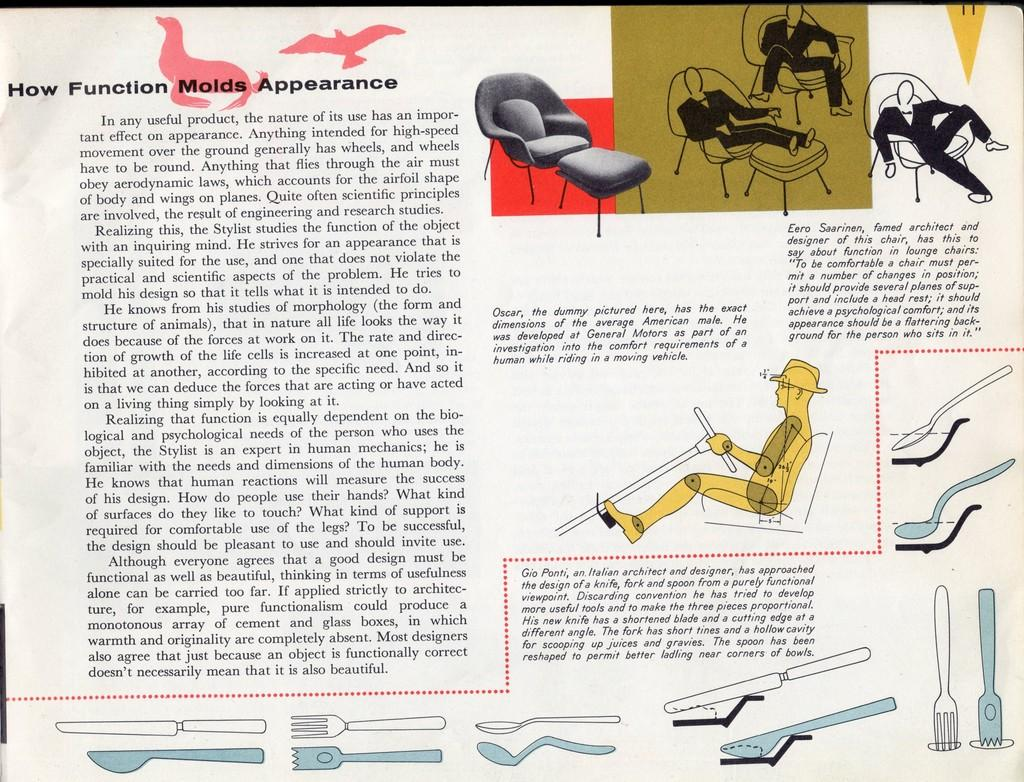What is the main subject of the newspaper picture in the image? The main subject of the newspaper picture in the image is a scene that contains spoons, forks, birds, chairs, and four persons' paintings. What type of utensils are depicted in the newspaper picture? The newspaper picture contains spoons and forks. What type of animals are depicted in the newspaper picture? The newspaper picture contains birds. What type of furniture is depicted in the newspaper picture? The newspaper picture contains chairs. How many persons' paintings are depicted in the newspaper picture? Four persons' paintings are depicted in the newspaper picture. What type of jeans are worn by the pig in the image? There is no pig or jeans present in the image. Can you describe the group of animals in the image? There are no animals present in the image, only birds. 